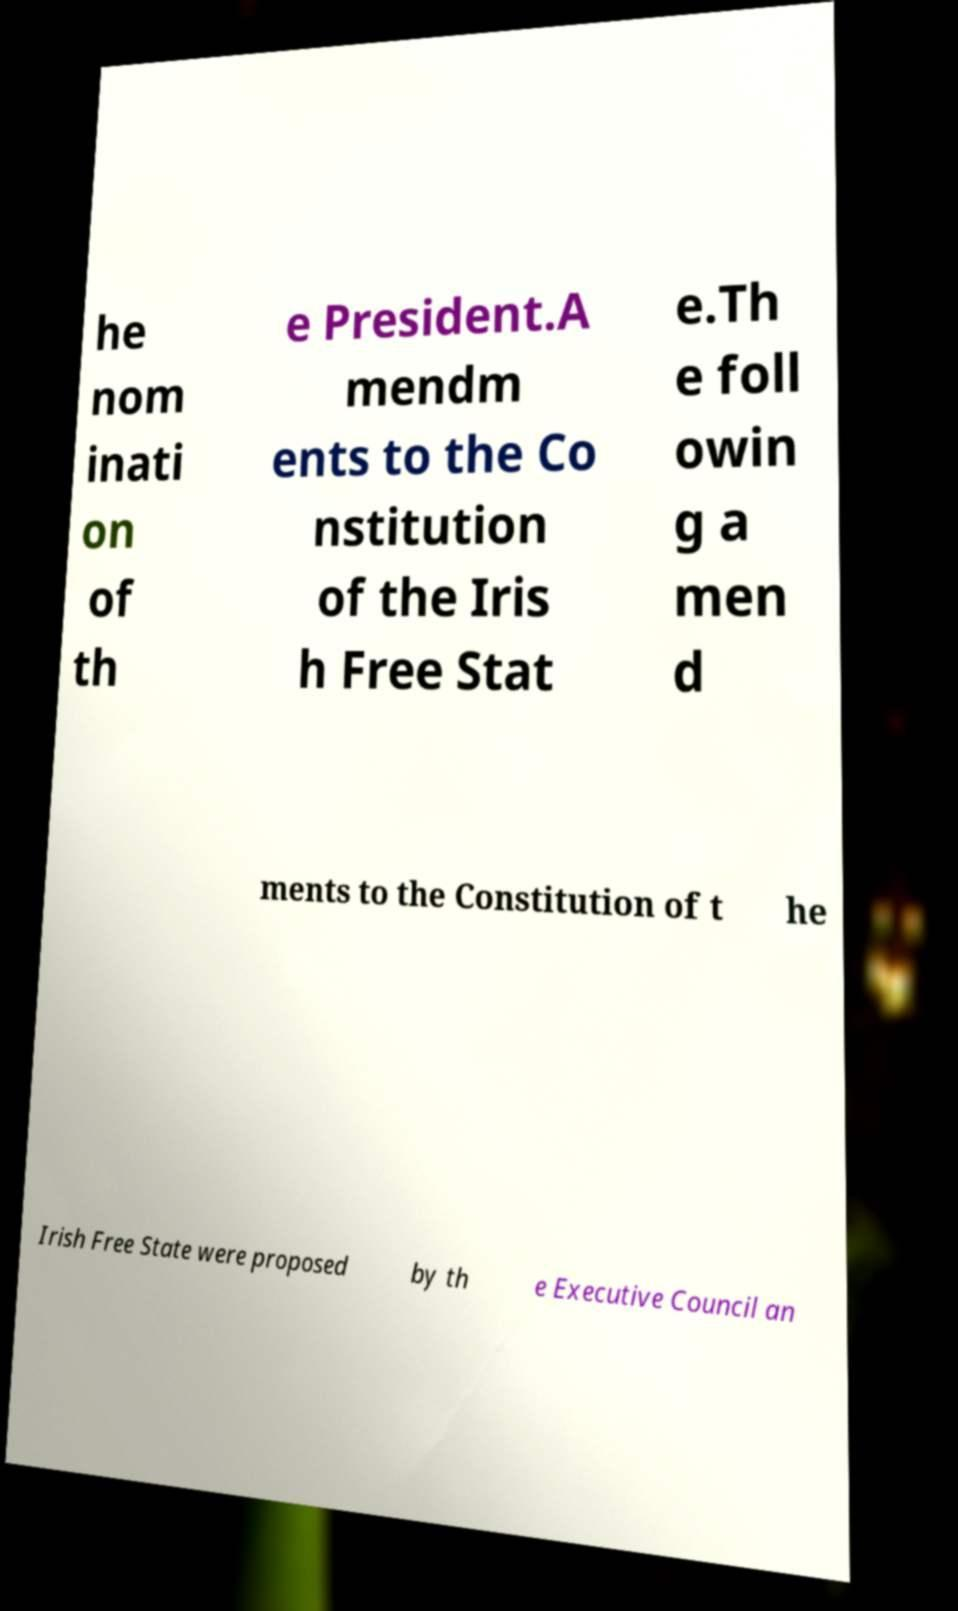Can you read and provide the text displayed in the image?This photo seems to have some interesting text. Can you extract and type it out for me? he nom inati on of th e President.A mendm ents to the Co nstitution of the Iris h Free Stat e.Th e foll owin g a men d ments to the Constitution of t he Irish Free State were proposed by th e Executive Council an 